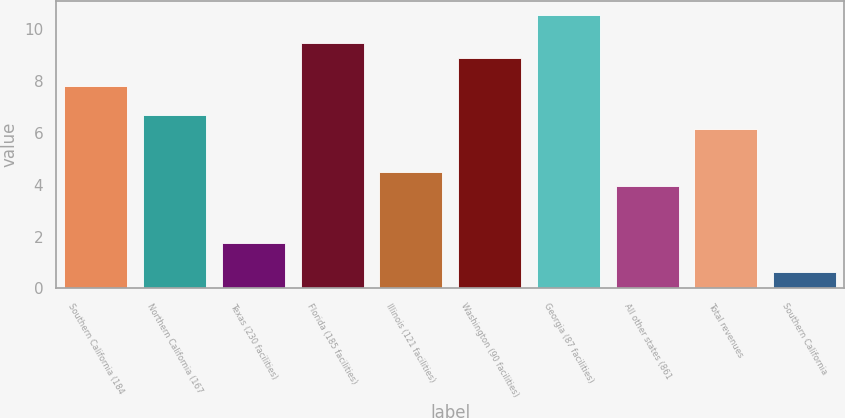<chart> <loc_0><loc_0><loc_500><loc_500><bar_chart><fcel>Southern California (184<fcel>Northern California (167<fcel>Texas (230 facilities)<fcel>Florida (185 facilities)<fcel>Illinois (121 facilities)<fcel>Washington (90 facilities)<fcel>Georgia (87 facilities)<fcel>All other states (861<fcel>Total revenues<fcel>Southern California<nl><fcel>7.8<fcel>6.7<fcel>1.75<fcel>9.45<fcel>4.5<fcel>8.9<fcel>10.55<fcel>3.95<fcel>6.15<fcel>0.65<nl></chart> 